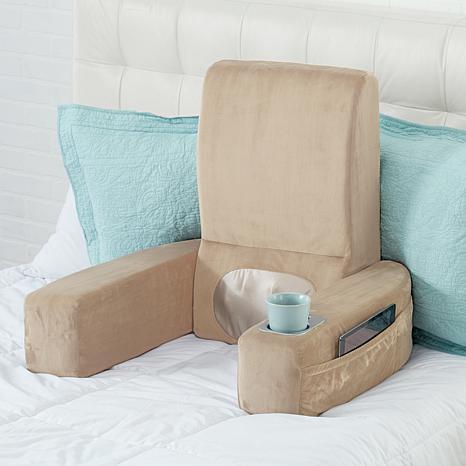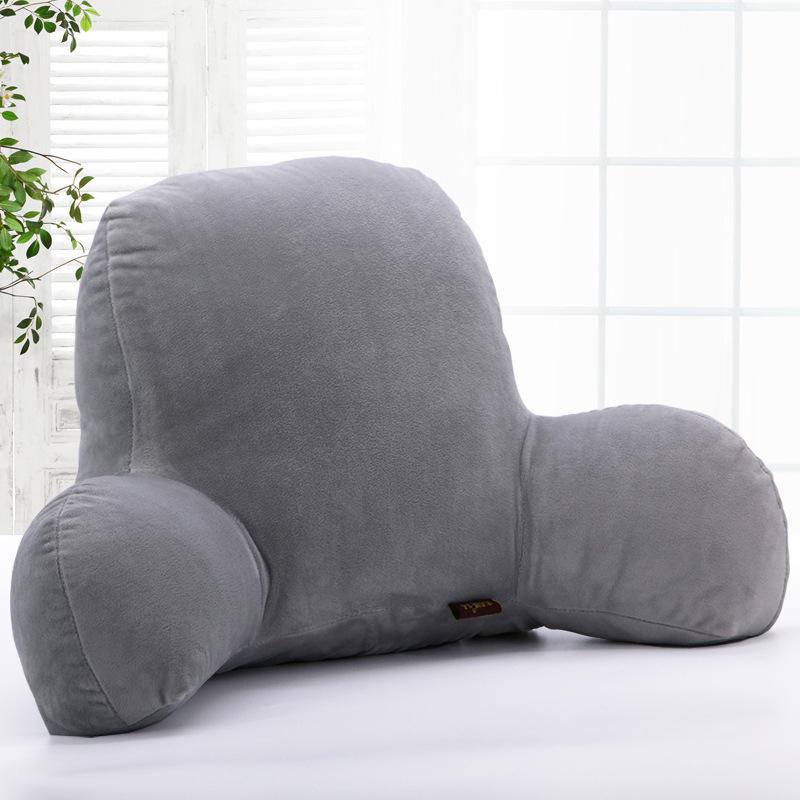The first image is the image on the left, the second image is the image on the right. For the images shown, is this caption "One or more images shows a backrest pillow holding a cup in a cup holder on one of the arms along with items in a side pocket" true? Answer yes or no. Yes. The first image is the image on the left, the second image is the image on the right. Given the left and right images, does the statement "At least one image features an upright bedrest with a cupholder and pouch in one arm." hold true? Answer yes or no. Yes. 